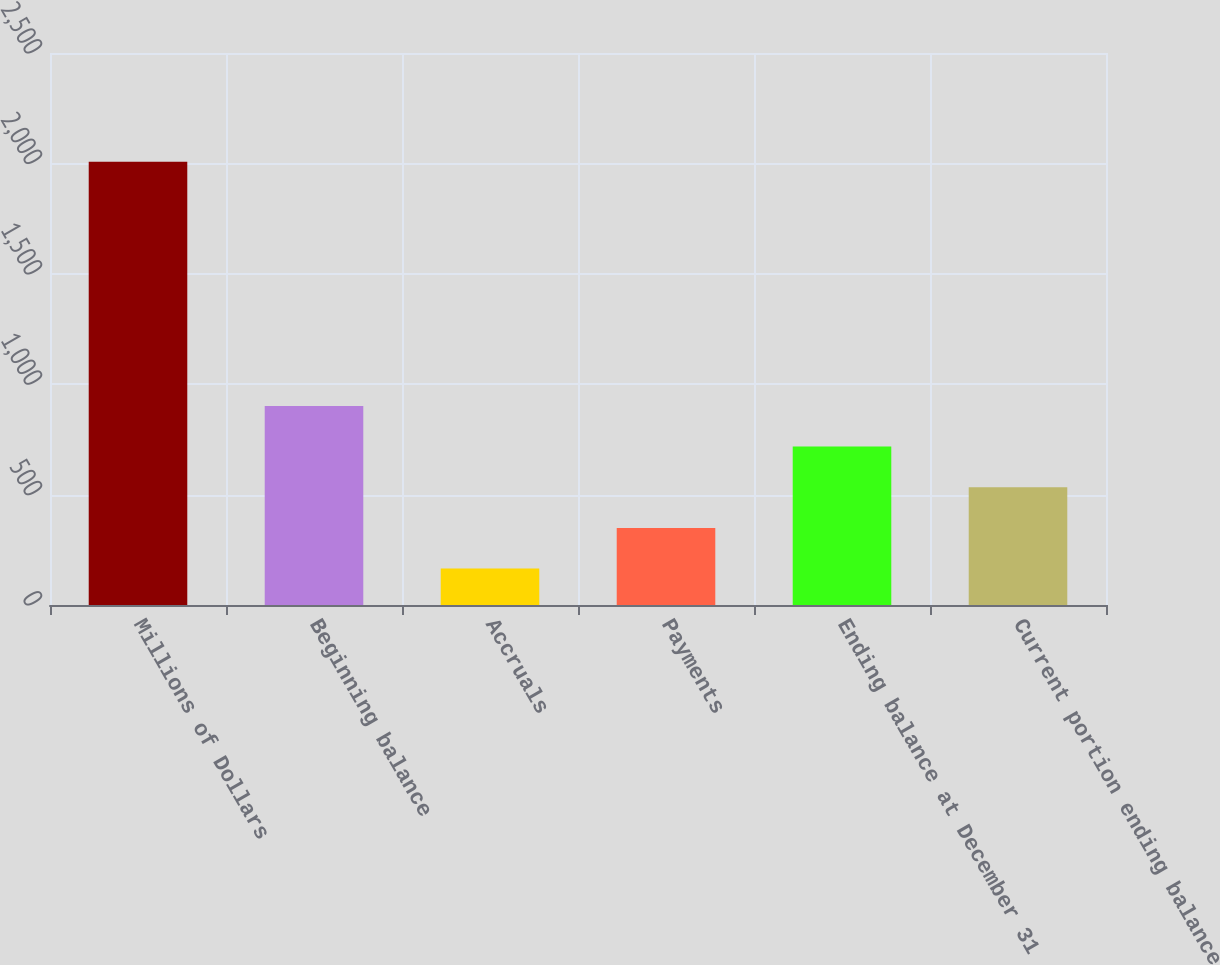Convert chart. <chart><loc_0><loc_0><loc_500><loc_500><bar_chart><fcel>Millions of Dollars<fcel>Beginning balance<fcel>Accruals<fcel>Payments<fcel>Ending balance at December 31<fcel>Current portion ending balance<nl><fcel>2007<fcel>901.8<fcel>165<fcel>349.2<fcel>717.6<fcel>533.4<nl></chart> 